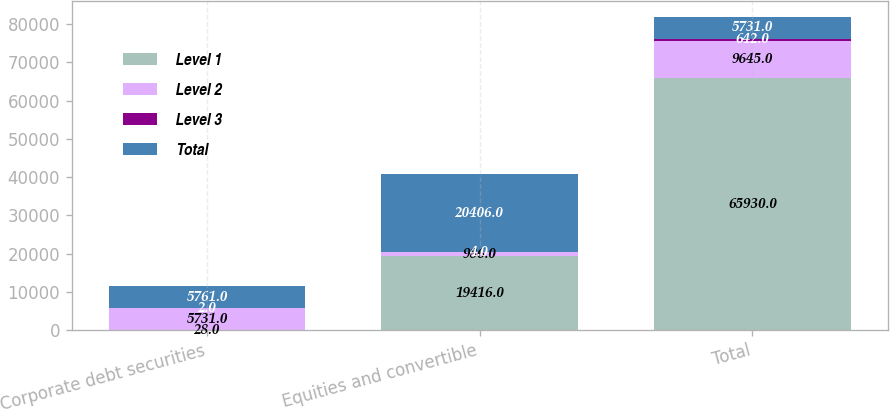Convert chart. <chart><loc_0><loc_0><loc_500><loc_500><stacked_bar_chart><ecel><fcel>Corporate debt securities<fcel>Equities and convertible<fcel>Total<nl><fcel>Level 1<fcel>28<fcel>19416<fcel>65930<nl><fcel>Level 2<fcel>5731<fcel>986<fcel>9645<nl><fcel>Level 3<fcel>2<fcel>4<fcel>642<nl><fcel>Total<fcel>5761<fcel>20406<fcel>5731<nl></chart> 